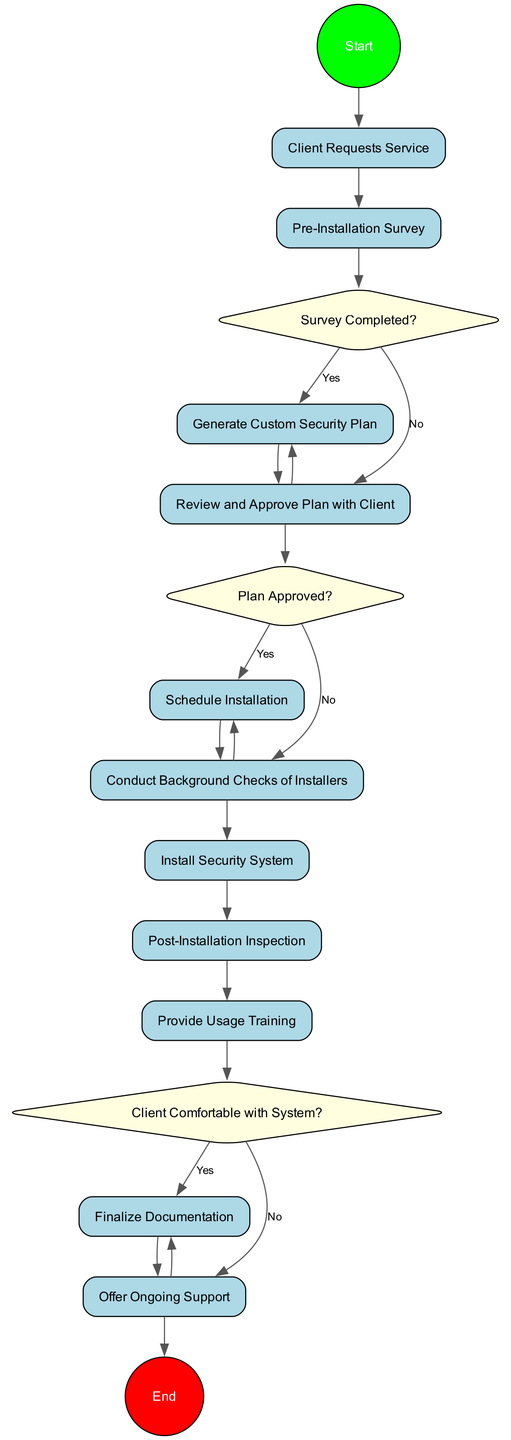What is the first activity in the diagram? The first activity is labeled as "Client Requests Service." This is the starting point of the onboarding process where the client contacts the company.
Answer: Client Requests Service How many decision points are in the diagram? There are three decision points in the diagram. They are: "Survey Completed?", "Plan Approved?", and "Client Comfortable with System?".
Answer: 3 What activity follows "Conduct Background Checks of Installers"? The activity that follows is "Install Security System." This activity comes after ensuring the installers have passed background checks.
Answer: Install Security System What is the last activity in the onboarding process? The last activity is "Offer Ongoing Support." This is the final step after completing all previous activities.
Answer: Offer Ongoing Support What happens if the client does not approve the plan? If the client does not approve the plan, the process would likely revert back to the creation of the custom plan after approval is declined. The specific steps may not be explicitly stated but typically involve revisiting the plan.
Answer: Generate Custom Security Plan How many total nodes are in the diagram? The total number of nodes, including activities and decisions, is twelve. This includes the start and end nodes as well.
Answer: 12 Which activity involves direct interaction with the client? The activity labeled "Review and Approve Plan with Client" involves direct interaction, as it requires the client to discuss and approve the proposed plan.
Answer: Review and Approve Plan with Client What is the purpose of the "Post-Installation Inspection"? The purpose is to conduct a final check to ensure the security system functions correctly and meets the client's needs after installation.
Answer: Ensure system functionality What decision is made after the post-installation inspection? The decision made after the post-installation inspection is "Client Comfortable with System?". This checks if the client understands and feels comfortable using the installed system.
Answer: Client Comfortable with System? 